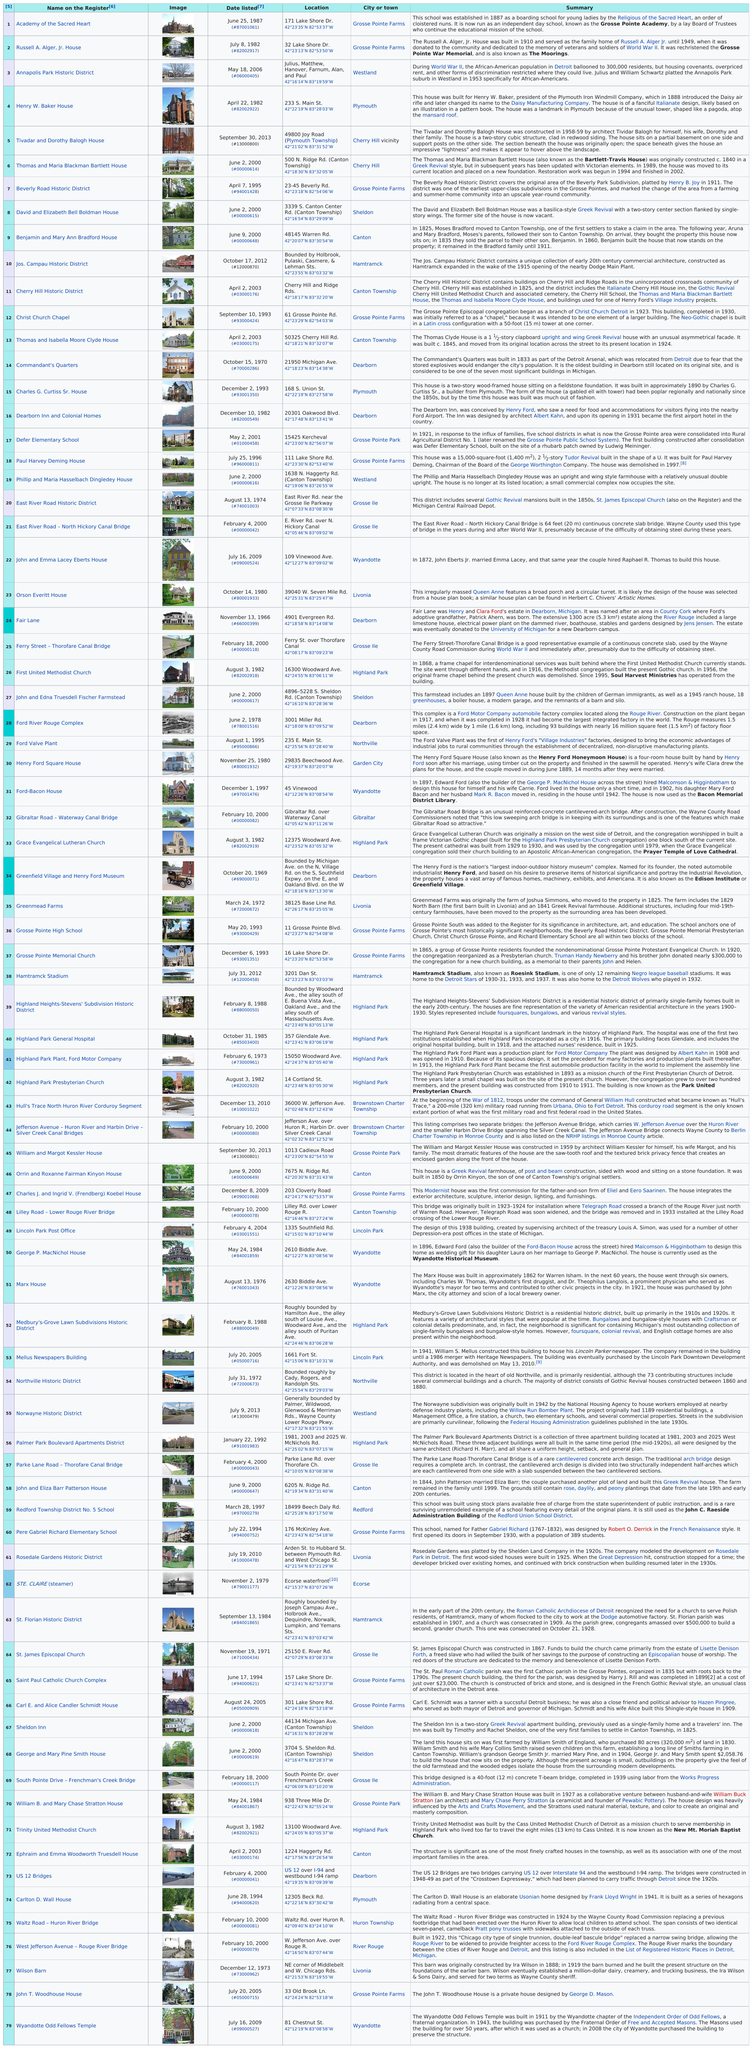Mention a couple of crucial points in this snapshot. As of 2010, a total of 74 properties were listed. The Academy of the Sacred Heart School was established before 1900, and the answer is yes. The Henry W. Baker House is the older of the two, having been built prior to the Annapolis Park Historic District. The fact is that the Academy of the Sacred Heart is located in the same city as another home that was dedicated to veterans and soldiers, specifically the Russell A. Alger, Jr. House. Hull's Trace, a historic site associated with the War of 1812, is the only such place in the area. It is a corduroy segment of the North Huron River that was used during the war to transport troops and supplies. 